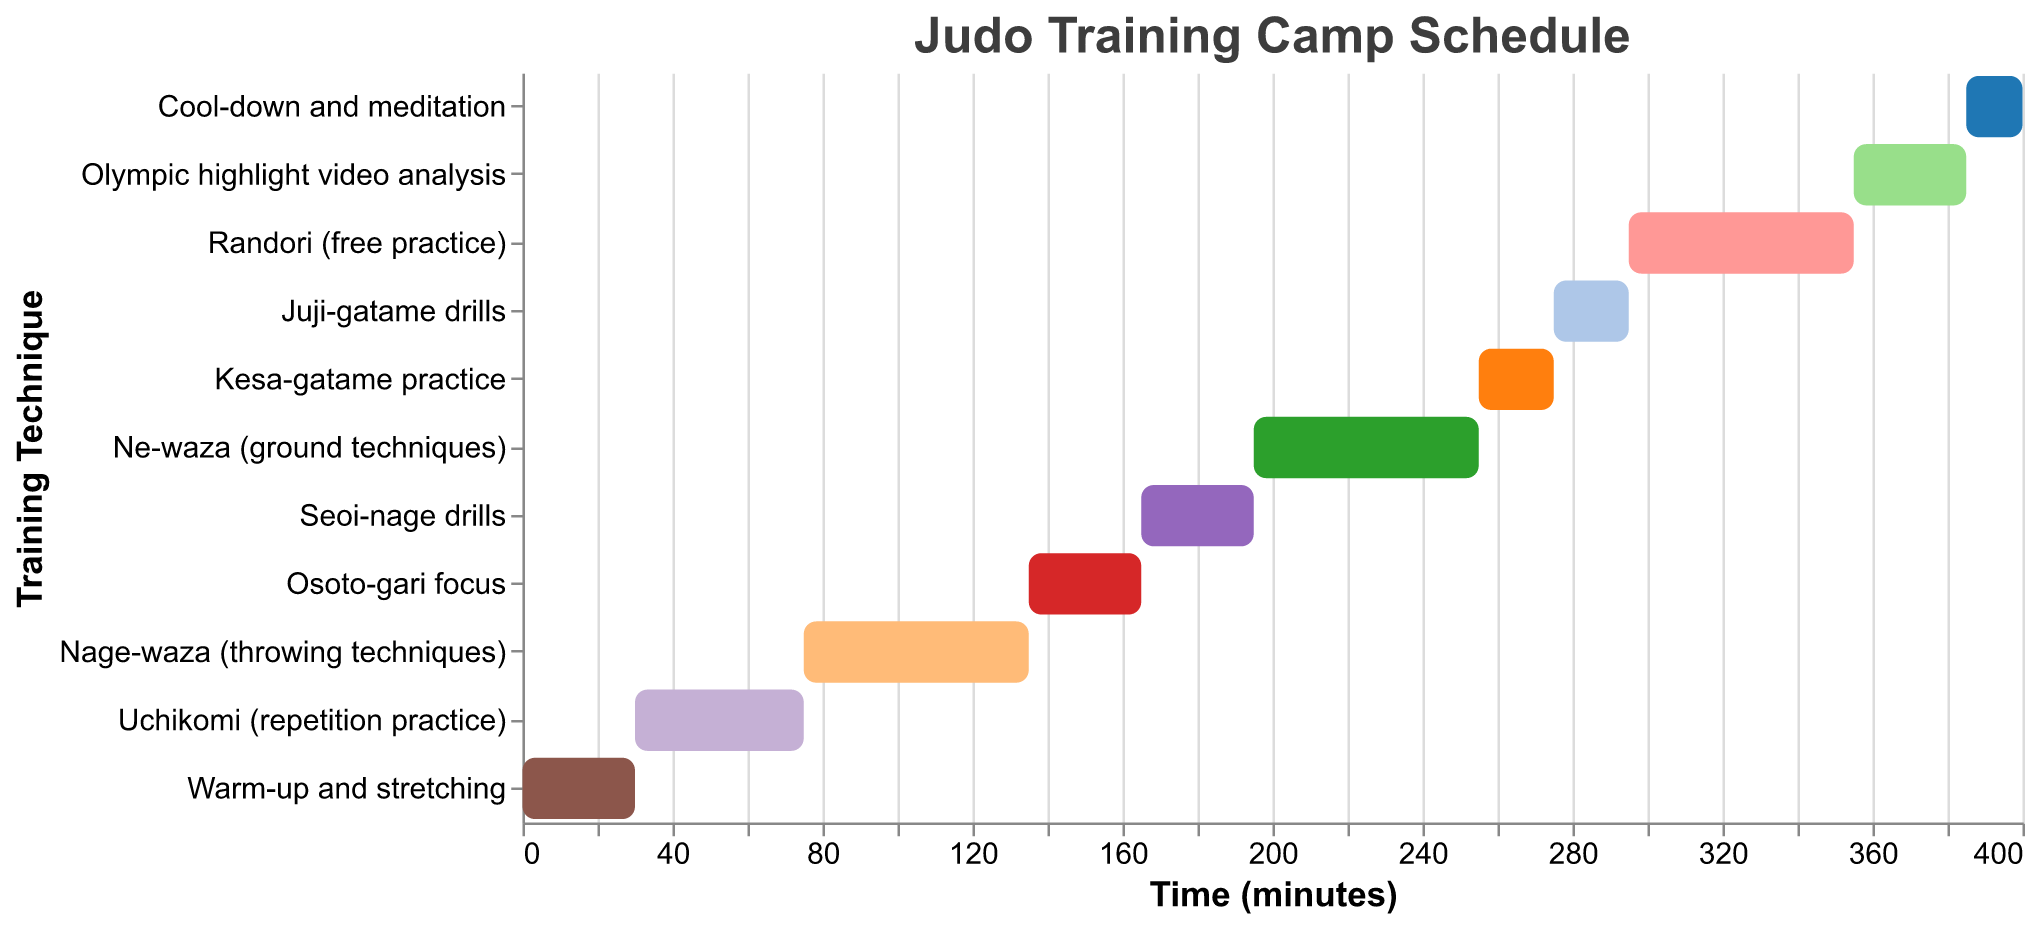What's the title of the Gantt Chart? The title is usually positioned at the top of the chart. In this case, the title is displayed prominently, making it easy to identify.
Answer: Judo Training Camp Schedule Which technique starts after "Uchikomi (repetition practice)"? From the Gantt Chart, "Uchikomi (repetition practice)" starts at 30 minutes and ends at 75 minutes. The next scheduled technique starts right after at 75 minutes.
Answer: Nage-waza (throwing techniques) How much time is allocated for "Randori (free practice)"? We look at the chart to find the "Randori (free practice)" technique. Its duration is displayed, allowing us to read the corresponding time.
Answer: 60 minutes What is the total duration for all techniques involving ground techniques (Ne-waza, Kesa-gatame, Juji-gatame)? Sum the durations of "Ne-waza" (60 minutes), "Kesa-gatame" (20 minutes), and "Juji-gatame" (20 minutes). The total is 60 + 20 + 20.
Answer: 100 minutes Which technique has the shortest duration? Review the durations specified in the chart to find the smallest value. The technique with the shortest duration stands out.
Answer: Cool-down and meditation What is the start time difference between "Osoto-gari focus" and "Seoi-nage drills"? "Osoto-gari focus" starts at 135 minutes and "Seoi-nage drills" starts at 165 minutes. Calculate the difference by subtracting 135 from 165.
Answer: 30 minutes How does the time allocated to "Ne-waza" compare to the time allocated to "Nage-waza"? Look at the durations for "Ne-waza" and "Nage-waza" in the chart. Both have their times indicated, allowing us to directly compare them.
Answer: Equal (both 60 minutes) How long is the total warm-up and cool-down period combined? Add the duration of "Warm-up and stretching" (30 minutes) and "Cool-down and meditation" (15 minutes). The sum is 30 + 15.
Answer: 45 minutes What segment follows directly after "Nage-waza"? Locate "Nage-waza" on the chart, which ends at 135 minutes. Look for the next entry, which starts right after at the same time.
Answer: Osoto-gari focus Add up the duration of all individual techniques from start to finish. Sum all the individual durations listed: 30 + 45 + 60 + 30 + 30 + 60 + 20 + 20 + 60 + 30 + 15. The total of these values gives the complete duration spent on techniques.
Answer: 400 minutes 